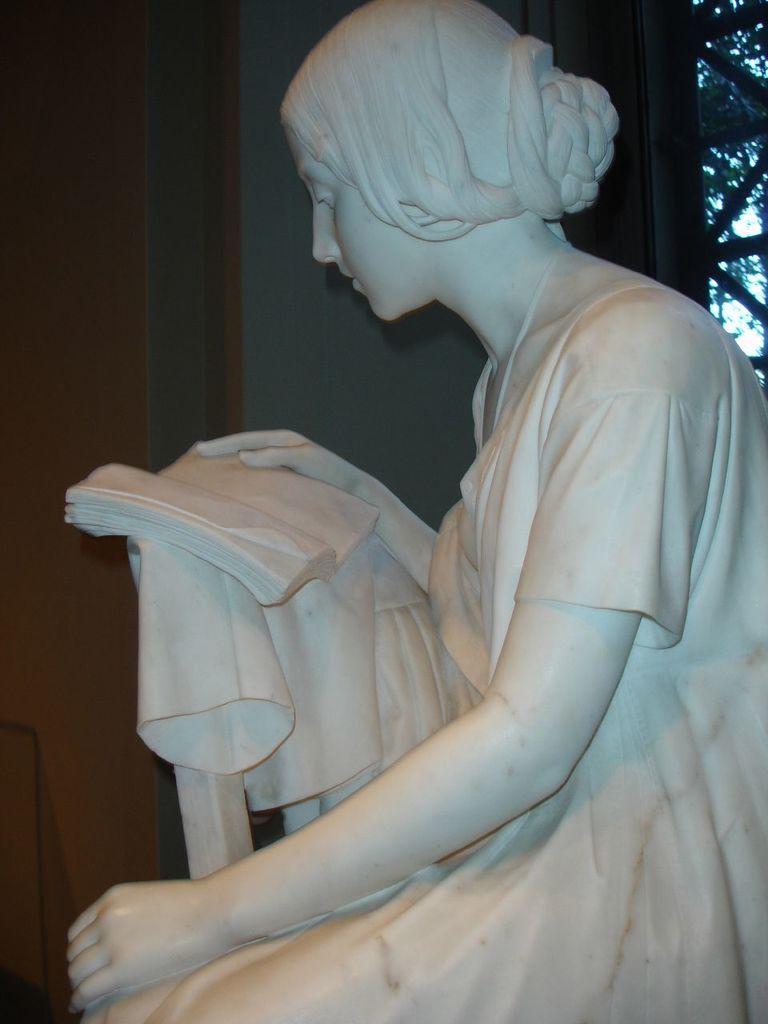Describe this image in one or two sentences. In this picture we can see a statue, in the background we can find few trees. 